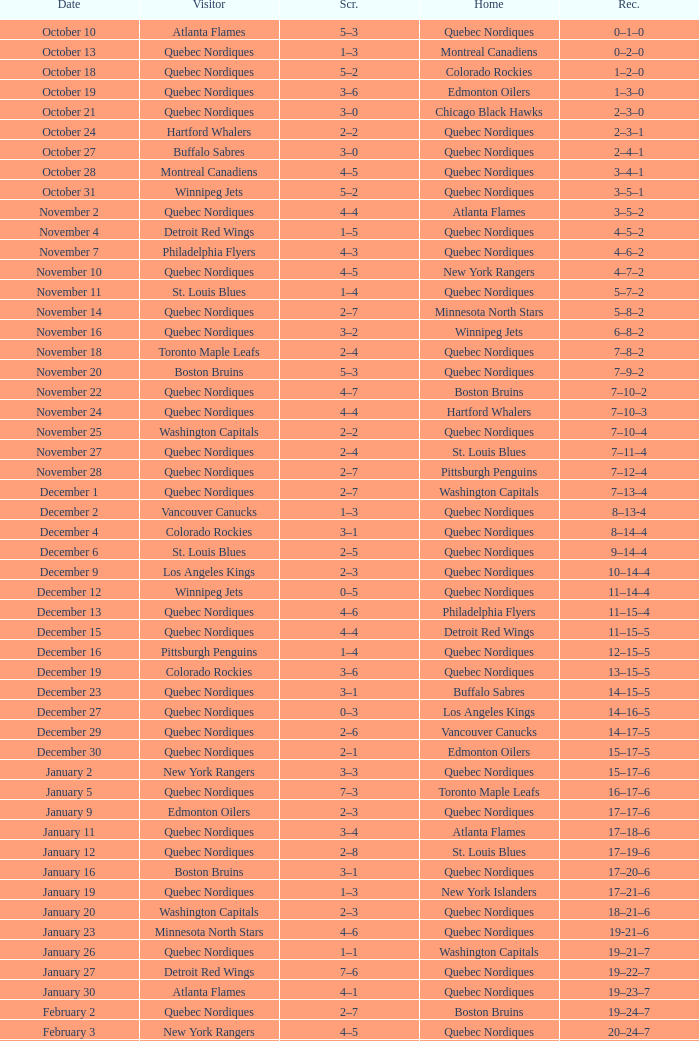Which Date has a Score of 2–7, and a Record of 5–8–2? November 14. 